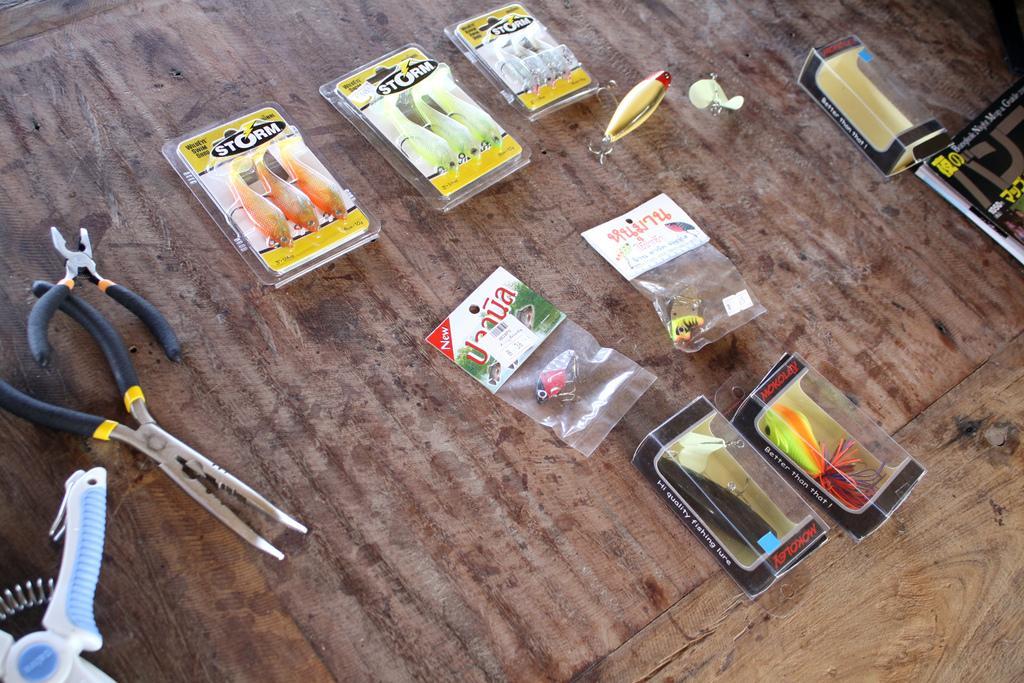Please provide a concise description of this image. In this image I can see on the left side there is a cutting plier in black color and other tools. In the middle there are toys in the shape of fishes and other insects on a wooden table. 